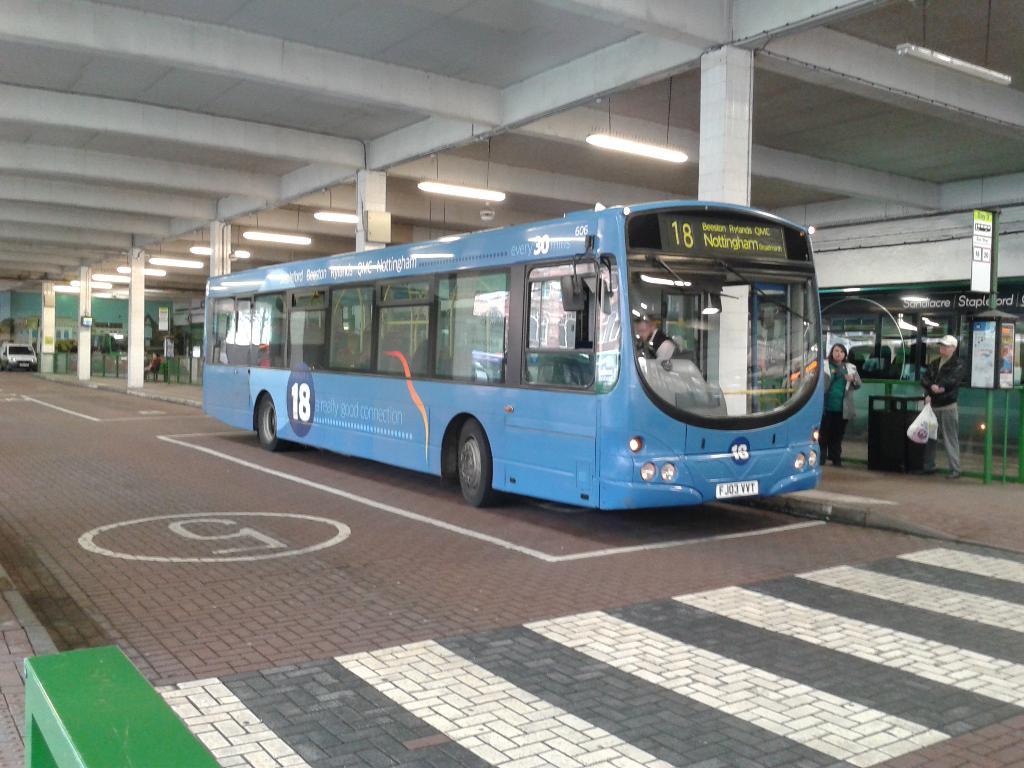What number is in the circle on the road?
Your response must be concise. 5. 